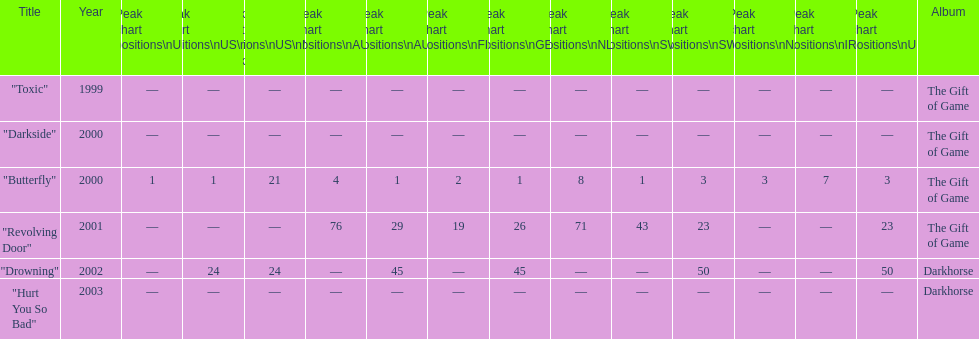Would you mind parsing the complete table? {'header': ['Title', 'Year', 'Peak chart positions\\nUS', 'Peak chart positions\\nUS\\nAlt.', 'Peak chart positions\\nUS\\nMain. Rock', 'Peak chart positions\\nAUS', 'Peak chart positions\\nAUT', 'Peak chart positions\\nFIN', 'Peak chart positions\\nGER', 'Peak chart positions\\nNLD', 'Peak chart positions\\nSWI', 'Peak chart positions\\nSWE', 'Peak chart positions\\nNZ', 'Peak chart positions\\nIRE', 'Peak chart positions\\nUK', 'Album'], 'rows': [['"Toxic"', '1999', '—', '—', '—', '—', '—', '—', '—', '—', '—', '—', '—', '—', '—', 'The Gift of Game'], ['"Darkside"', '2000', '—', '—', '—', '—', '—', '—', '—', '—', '—', '—', '—', '—', '—', 'The Gift of Game'], ['"Butterfly"', '2000', '1', '1', '21', '4', '1', '2', '1', '8', '1', '3', '3', '7', '3', 'The Gift of Game'], ['"Revolving Door"', '2001', '—', '—', '—', '76', '29', '19', '26', '71', '43', '23', '—', '—', '23', 'The Gift of Game'], ['"Drowning"', '2002', '—', '24', '24', '—', '45', '—', '45', '—', '—', '50', '—', '—', '50', 'Darkhorse'], ['"Hurt You So Bad"', '2003', '—', '—', '—', '—', '—', '—', '—', '—', '—', '—', '—', '—', '—', 'Darkhorse']]} Which single ranks 1 in us and 1 in us alt? "Butterfly". 